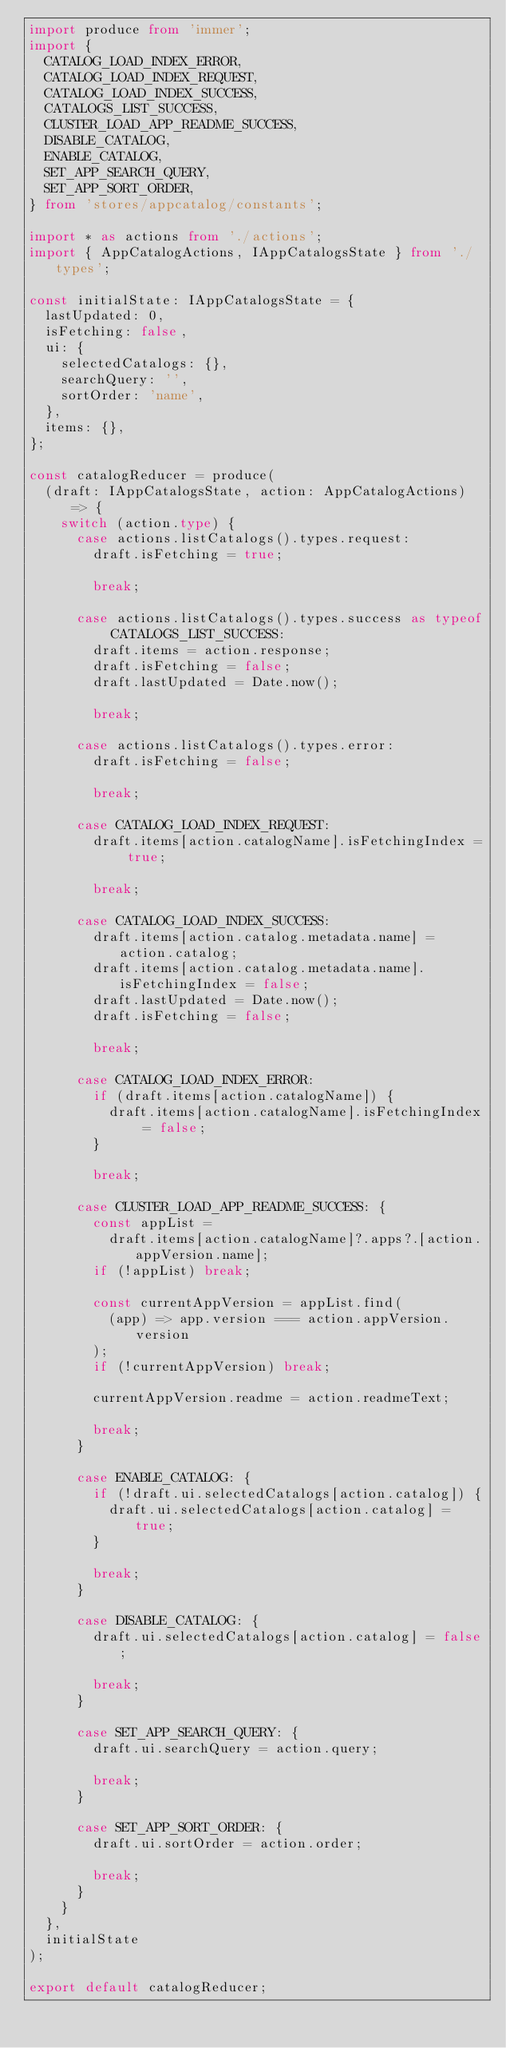<code> <loc_0><loc_0><loc_500><loc_500><_TypeScript_>import produce from 'immer';
import {
  CATALOG_LOAD_INDEX_ERROR,
  CATALOG_LOAD_INDEX_REQUEST,
  CATALOG_LOAD_INDEX_SUCCESS,
  CATALOGS_LIST_SUCCESS,
  CLUSTER_LOAD_APP_README_SUCCESS,
  DISABLE_CATALOG,
  ENABLE_CATALOG,
  SET_APP_SEARCH_QUERY,
  SET_APP_SORT_ORDER,
} from 'stores/appcatalog/constants';

import * as actions from './actions';
import { AppCatalogActions, IAppCatalogsState } from './types';

const initialState: IAppCatalogsState = {
  lastUpdated: 0,
  isFetching: false,
  ui: {
    selectedCatalogs: {},
    searchQuery: '',
    sortOrder: 'name',
  },
  items: {},
};

const catalogReducer = produce(
  (draft: IAppCatalogsState, action: AppCatalogActions) => {
    switch (action.type) {
      case actions.listCatalogs().types.request:
        draft.isFetching = true;

        break;

      case actions.listCatalogs().types.success as typeof CATALOGS_LIST_SUCCESS:
        draft.items = action.response;
        draft.isFetching = false;
        draft.lastUpdated = Date.now();

        break;

      case actions.listCatalogs().types.error:
        draft.isFetching = false;

        break;

      case CATALOG_LOAD_INDEX_REQUEST:
        draft.items[action.catalogName].isFetchingIndex = true;

        break;

      case CATALOG_LOAD_INDEX_SUCCESS:
        draft.items[action.catalog.metadata.name] = action.catalog;
        draft.items[action.catalog.metadata.name].isFetchingIndex = false;
        draft.lastUpdated = Date.now();
        draft.isFetching = false;

        break;

      case CATALOG_LOAD_INDEX_ERROR:
        if (draft.items[action.catalogName]) {
          draft.items[action.catalogName].isFetchingIndex = false;
        }

        break;

      case CLUSTER_LOAD_APP_README_SUCCESS: {
        const appList =
          draft.items[action.catalogName]?.apps?.[action.appVersion.name];
        if (!appList) break;

        const currentAppVersion = appList.find(
          (app) => app.version === action.appVersion.version
        );
        if (!currentAppVersion) break;

        currentAppVersion.readme = action.readmeText;

        break;
      }

      case ENABLE_CATALOG: {
        if (!draft.ui.selectedCatalogs[action.catalog]) {
          draft.ui.selectedCatalogs[action.catalog] = true;
        }

        break;
      }

      case DISABLE_CATALOG: {
        draft.ui.selectedCatalogs[action.catalog] = false;

        break;
      }

      case SET_APP_SEARCH_QUERY: {
        draft.ui.searchQuery = action.query;

        break;
      }

      case SET_APP_SORT_ORDER: {
        draft.ui.sortOrder = action.order;

        break;
      }
    }
  },
  initialState
);

export default catalogReducer;
</code> 